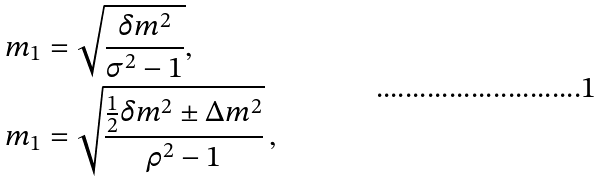<formula> <loc_0><loc_0><loc_500><loc_500>m _ { 1 } & = \sqrt { \frac { \delta m ^ { 2 } } { \sigma ^ { 2 } - 1 } } , \\ m _ { 1 } & = \sqrt { \frac { \frac { 1 } { 2 } \delta m ^ { 2 } \pm \Delta m ^ { 2 } } { \rho ^ { 2 } - 1 } } \, ,</formula> 